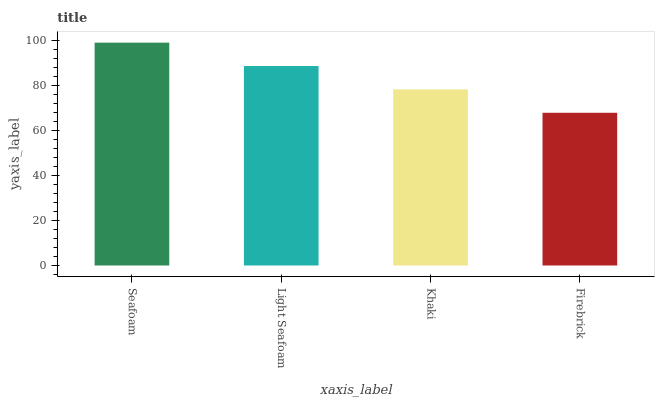Is Firebrick the minimum?
Answer yes or no. Yes. Is Seafoam the maximum?
Answer yes or no. Yes. Is Light Seafoam the minimum?
Answer yes or no. No. Is Light Seafoam the maximum?
Answer yes or no. No. Is Seafoam greater than Light Seafoam?
Answer yes or no. Yes. Is Light Seafoam less than Seafoam?
Answer yes or no. Yes. Is Light Seafoam greater than Seafoam?
Answer yes or no. No. Is Seafoam less than Light Seafoam?
Answer yes or no. No. Is Light Seafoam the high median?
Answer yes or no. Yes. Is Khaki the low median?
Answer yes or no. Yes. Is Khaki the high median?
Answer yes or no. No. Is Firebrick the low median?
Answer yes or no. No. 